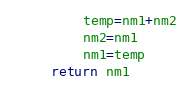<code> <loc_0><loc_0><loc_500><loc_500><_Python_>        temp=nm1+nm2
        nm2=nm1
        nm1=temp
    return nm1</code> 